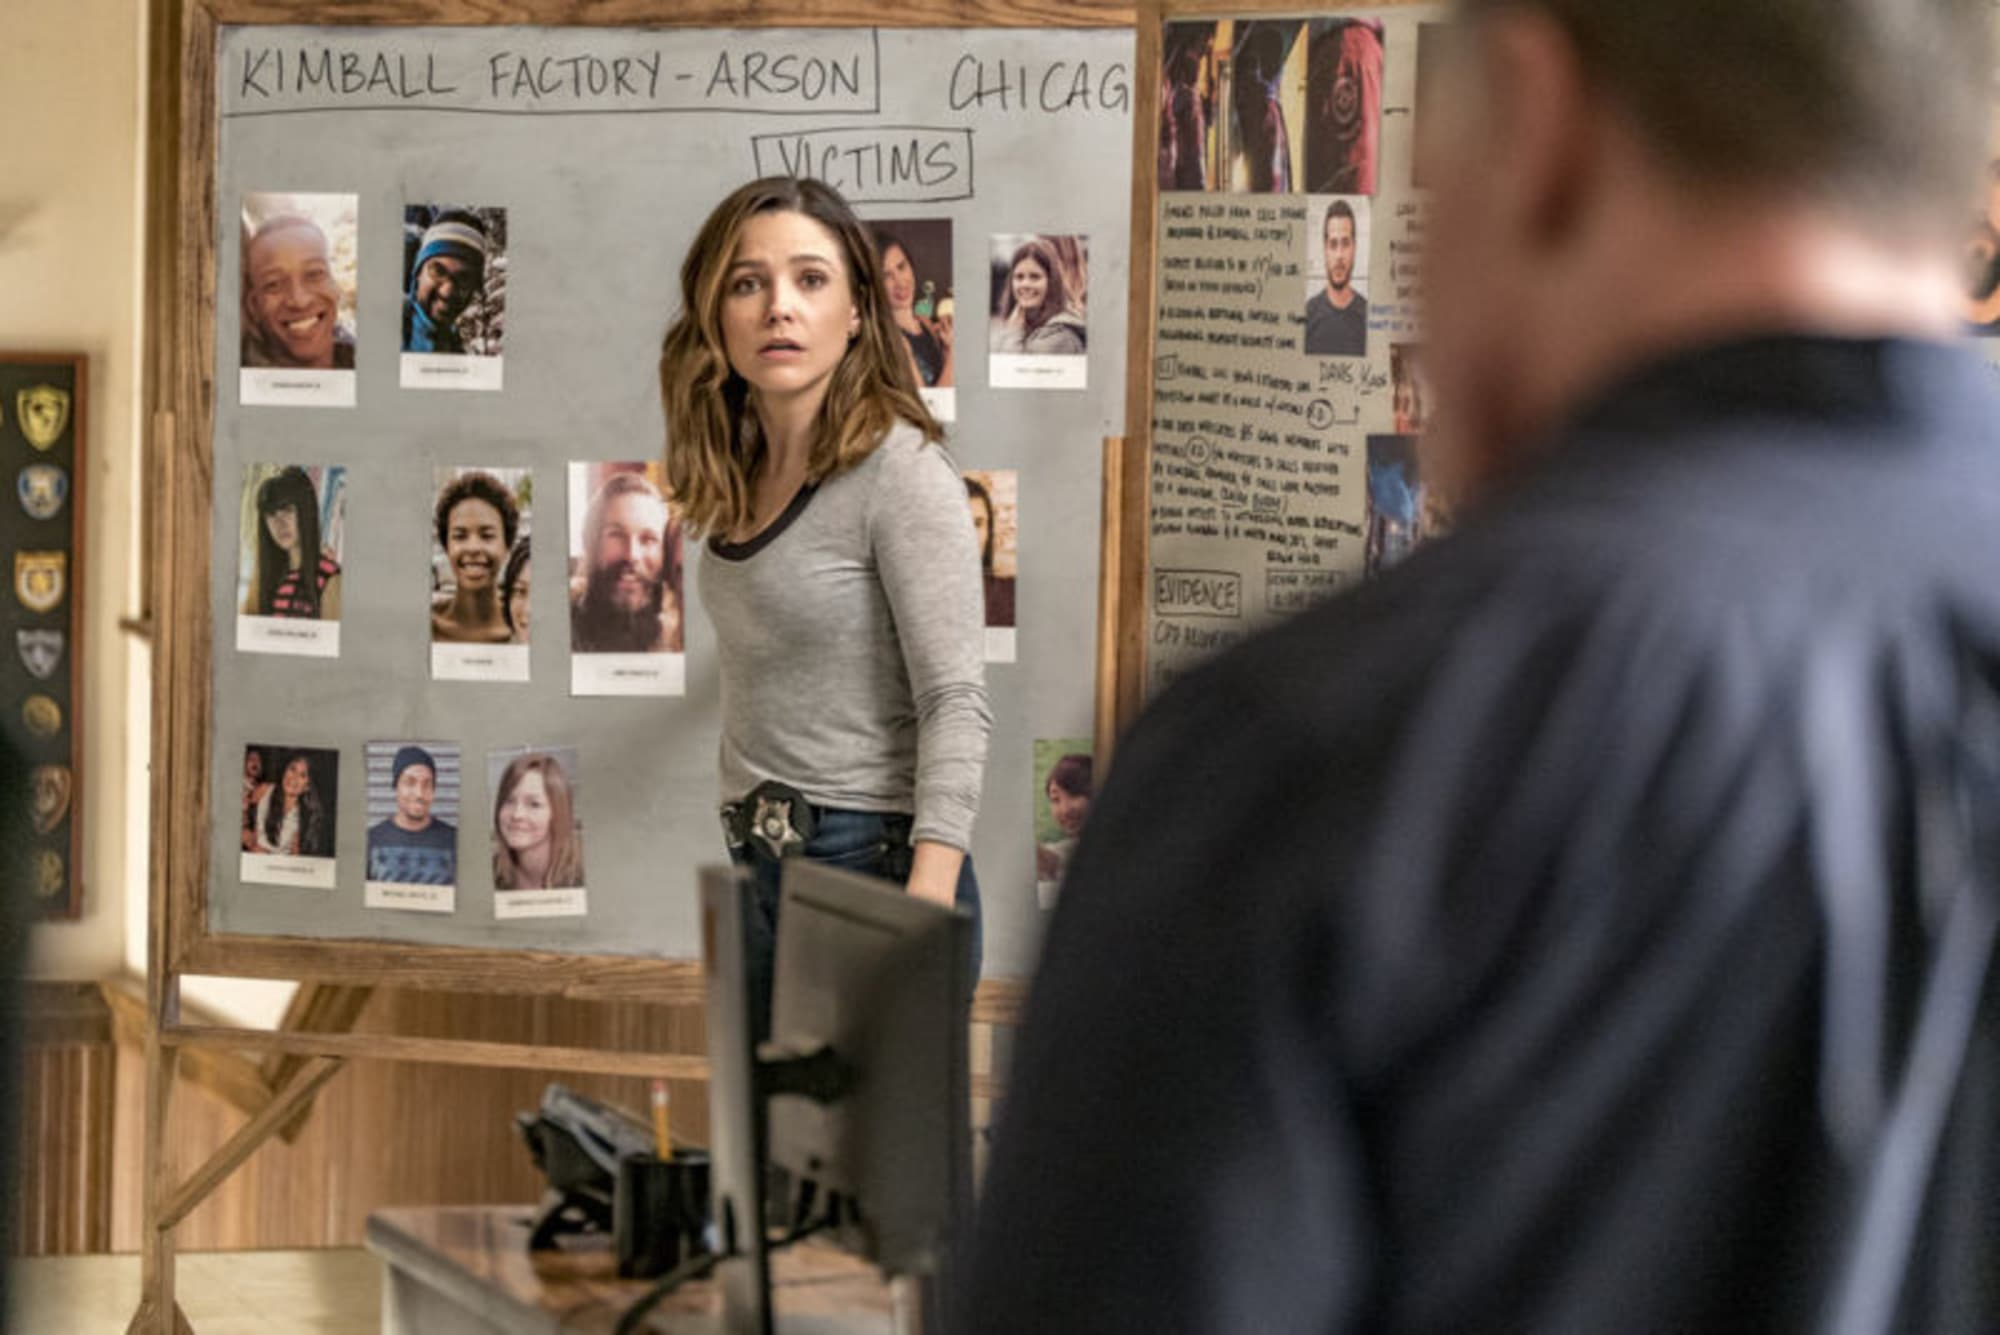Describe the following image. The image captures a tense moment within a detailed investigation scene. A woman, dressed in a casual gray sweater and jeans, stands in front focusing intently on a bulletin board labeled 'KIMBALL FACTORY-ARSON', 'CHICAGO', and 'VICTIMS'. These words suggest the severity of the case, involving multiple victims whose photos and brief identifiers are pinned up for review. The woman's expression, reflecting deep concern and commitment, hints at the emotional and professional weight of solving this case. Beside her, a man in police attire, seen from behind, also studies the board, indicating a shared effort in this investigation. 